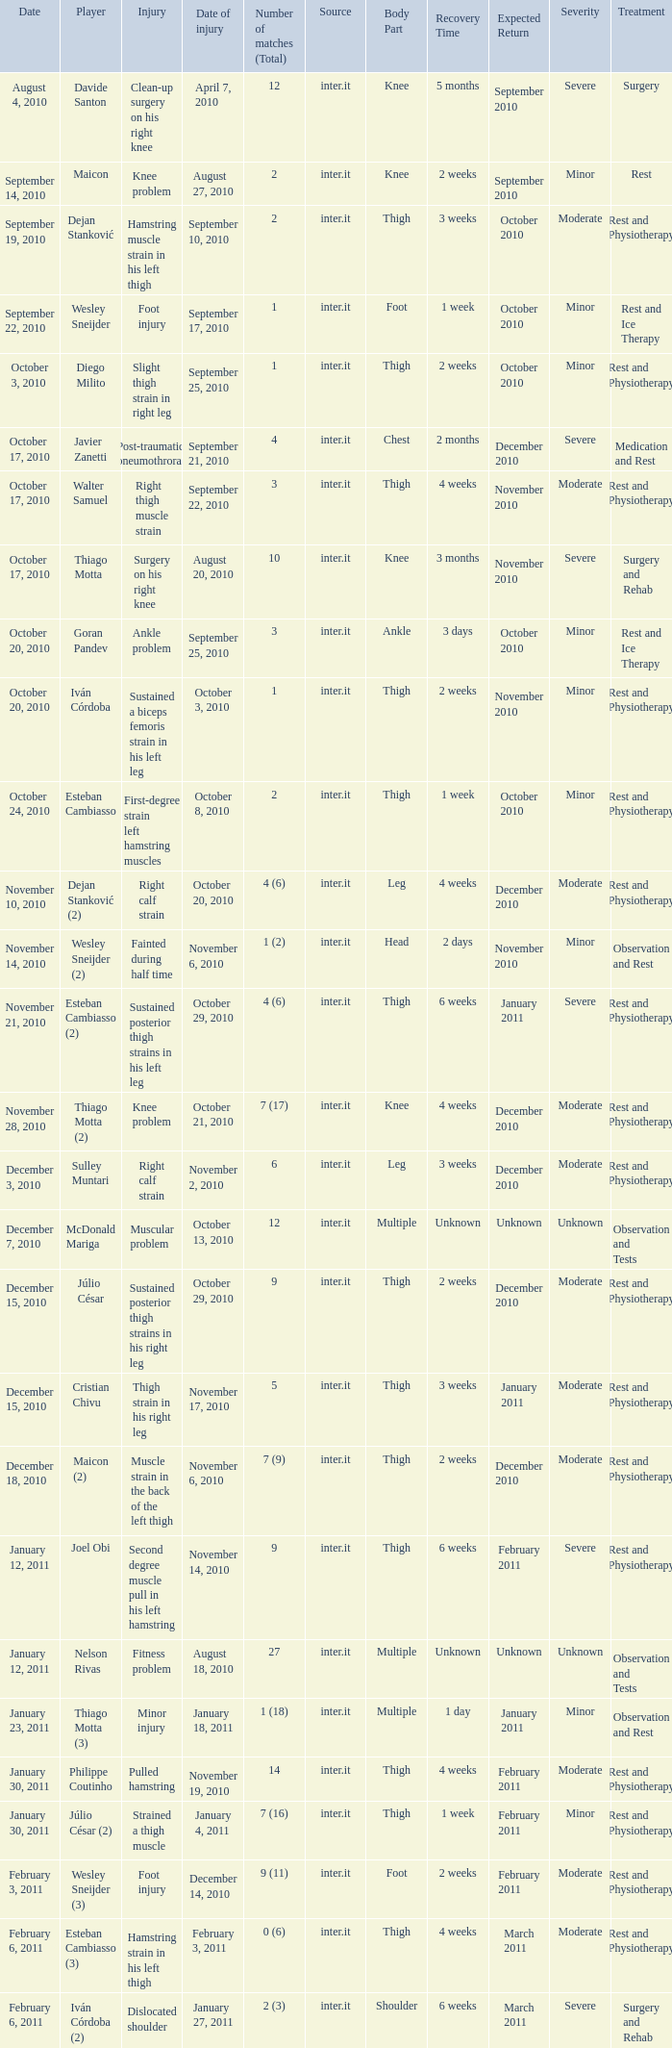What is the date of injury for player Wesley sneijder (2)? November 6, 2010. 